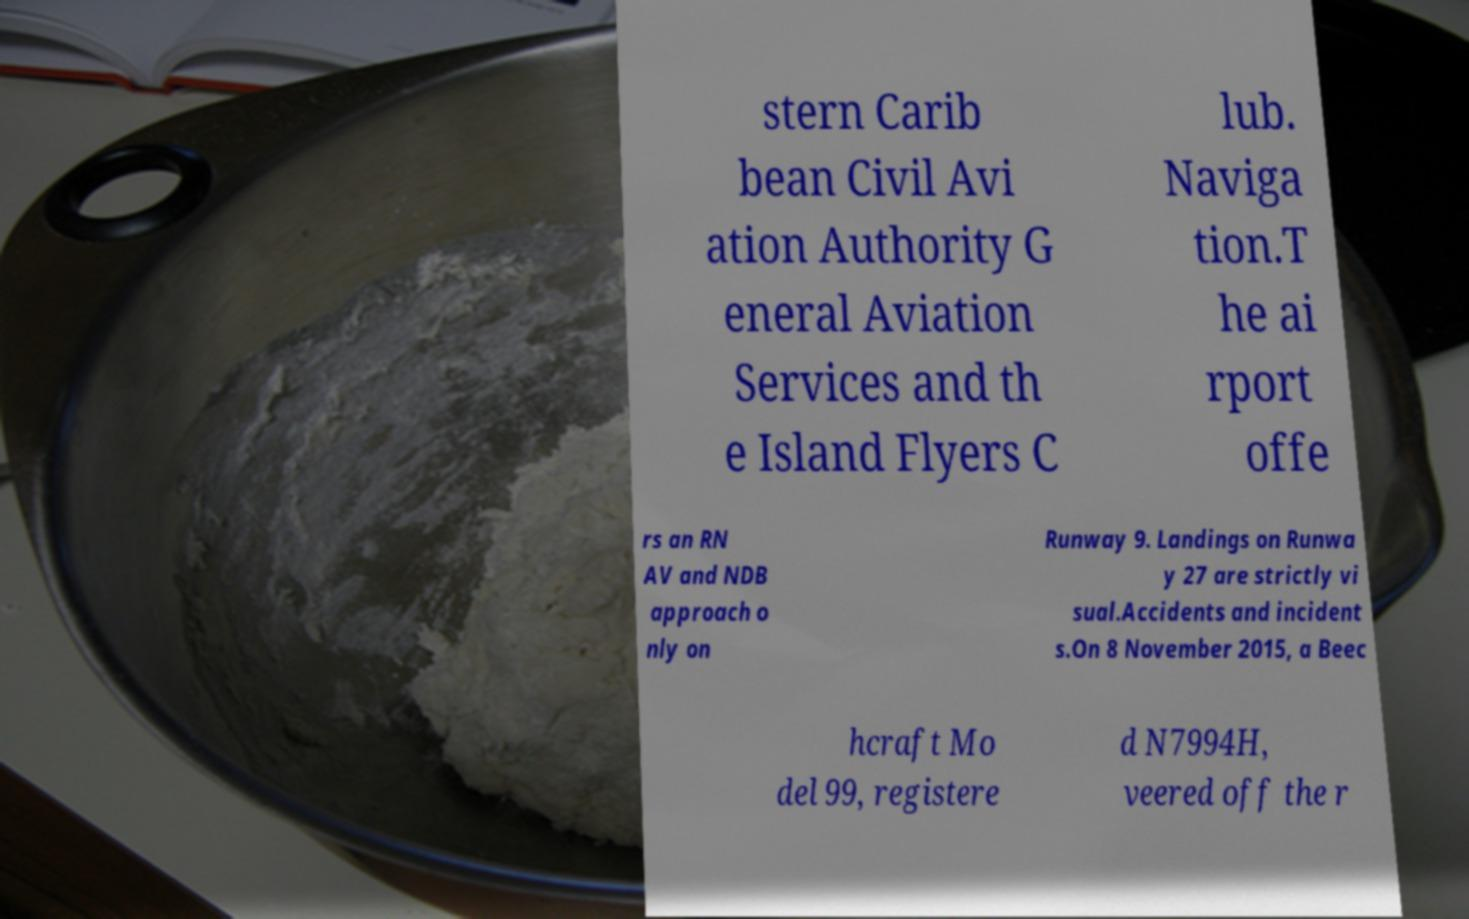There's text embedded in this image that I need extracted. Can you transcribe it verbatim? stern Carib bean Civil Avi ation Authority G eneral Aviation Services and th e Island Flyers C lub. Naviga tion.T he ai rport offe rs an RN AV and NDB approach o nly on Runway 9. Landings on Runwa y 27 are strictly vi sual.Accidents and incident s.On 8 November 2015, a Beec hcraft Mo del 99, registere d N7994H, veered off the r 